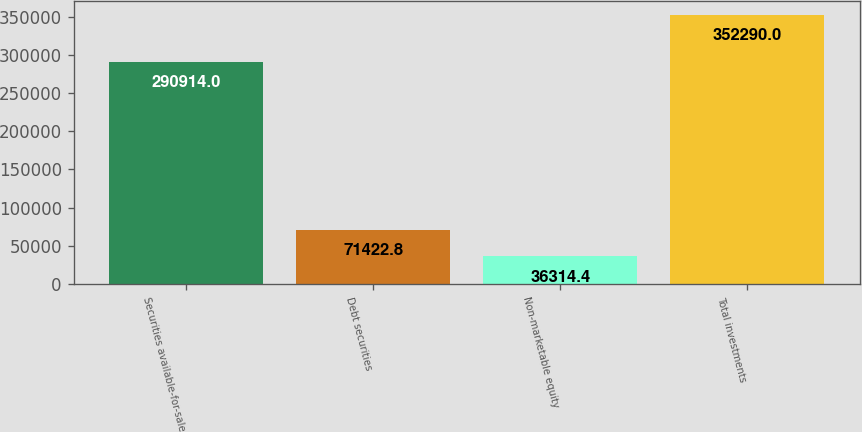Convert chart to OTSL. <chart><loc_0><loc_0><loc_500><loc_500><bar_chart><fcel>Securities available-for-sale<fcel>Debt securities<fcel>Non-marketable equity<fcel>Total investments<nl><fcel>290914<fcel>71422.8<fcel>36314.4<fcel>352290<nl></chart> 